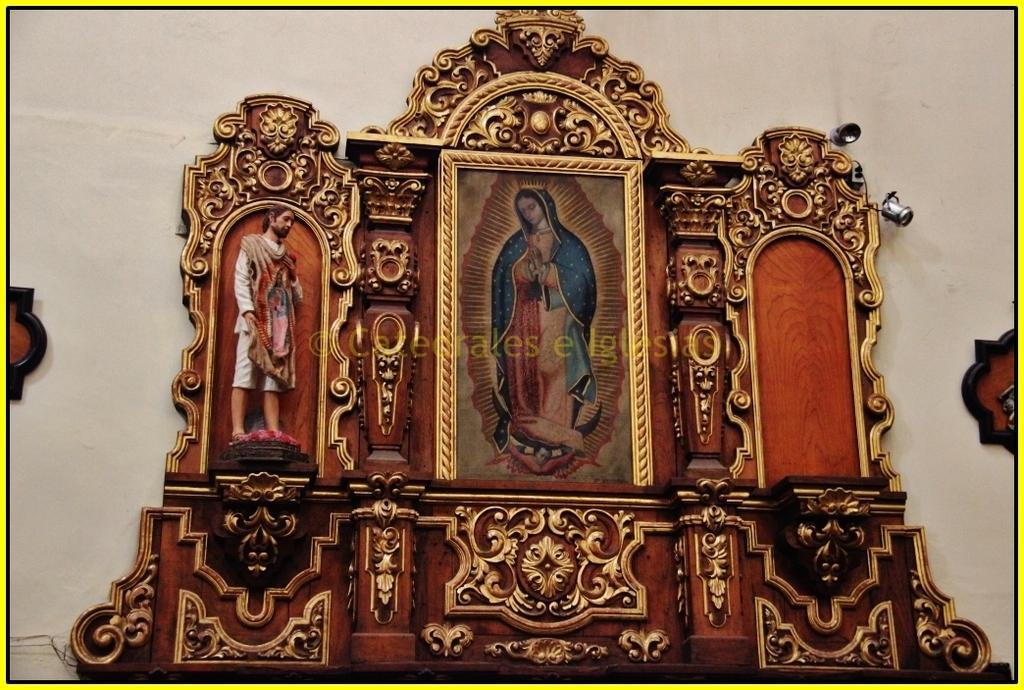How would you summarize this image in a sentence or two? In the middle of the image we can see a frame on the wall. 